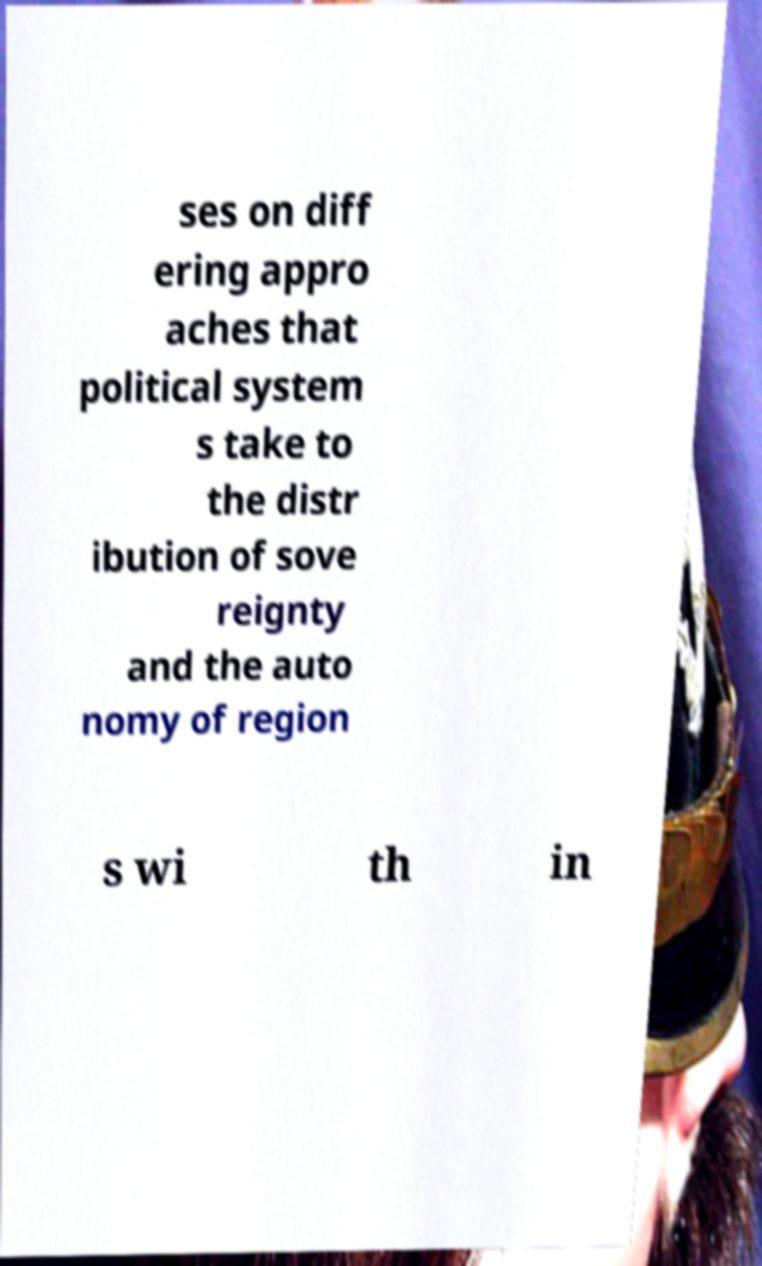For documentation purposes, I need the text within this image transcribed. Could you provide that? ses on diff ering appro aches that political system s take to the distr ibution of sove reignty and the auto nomy of region s wi th in 